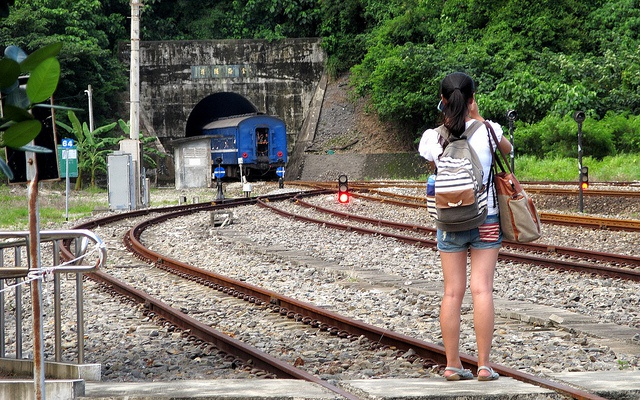Describe the objects in this image and their specific colors. I can see people in black, white, salmon, and darkgray tones, backpack in black, white, darkgray, and gray tones, train in black, blue, navy, and darkblue tones, handbag in black, gray, maroon, and darkgray tones, and traffic light in black, red, white, and darkgray tones in this image. 